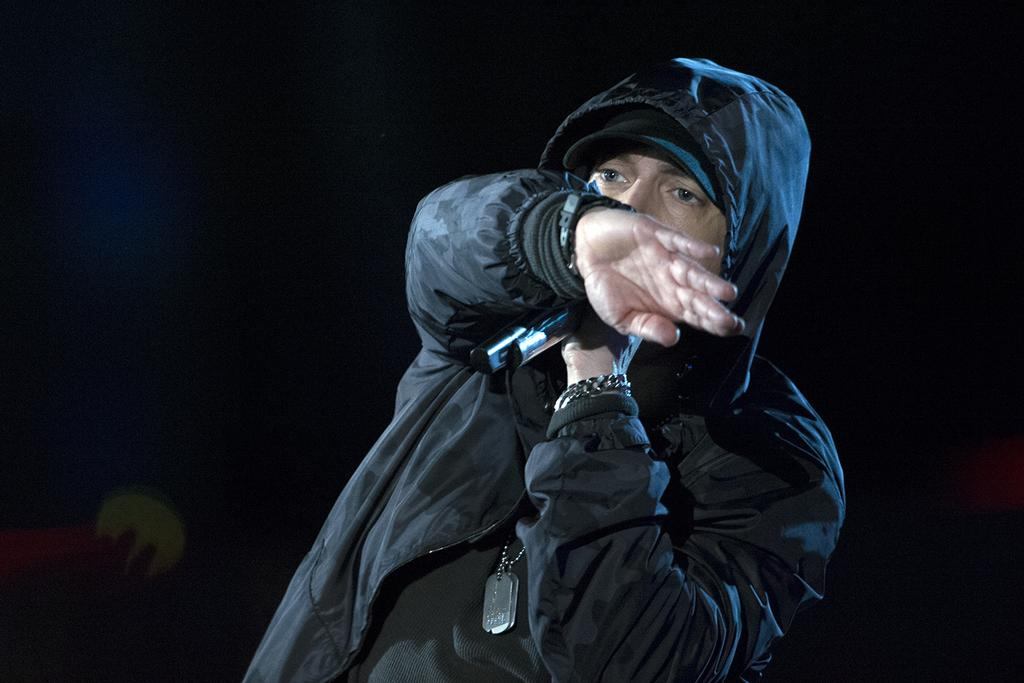What is the main subject of the image? The main subject of the image is a person standing in the center. What is the person holding in the image? The person is holding a microphone. What color jacket is the person wearing? The person is wearing a black color jacket. Is there a cat visible in the image? No, there is no cat present in the image. What type of operation is the person performing in the image? The image does not show any operation being performed; the person is simply holding a microphone. 